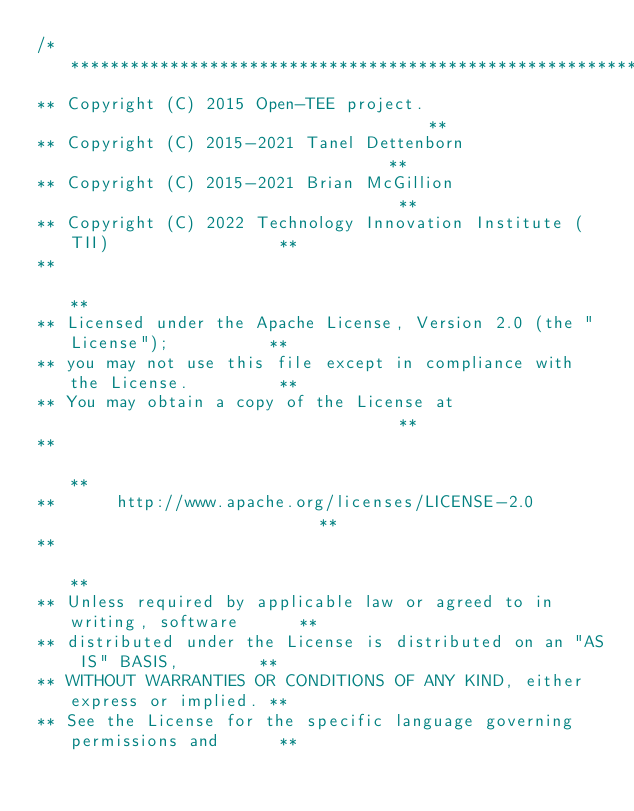Convert code to text. <code><loc_0><loc_0><loc_500><loc_500><_C_>/*****************************************************************************
** Copyright (C) 2015 Open-TEE project.	                                    **
** Copyright (C) 2015-2021 Tanel Dettenborn                                 **
** Copyright (C) 2015-2021 Brian McGillion                                  **
** Copyright (C) 2022 Technology Innovation Institute (TII)                 **
**                                                                          **
** Licensed under the Apache License, Version 2.0 (the "License");          **
** you may not use this file except in compliance with the License.         **
** You may obtain a copy of the License at                                  **
**                                                                          **
**      http://www.apache.org/licenses/LICENSE-2.0                          **
**                                                                          **
** Unless required by applicable law or agreed to in writing, software      **
** distributed under the License is distributed on an "AS IS" BASIS,        **
** WITHOUT WARRANTIES OR CONDITIONS OF ANY KIND, either express or implied. **
** See the License for the specific language governing permissions and      **</code> 